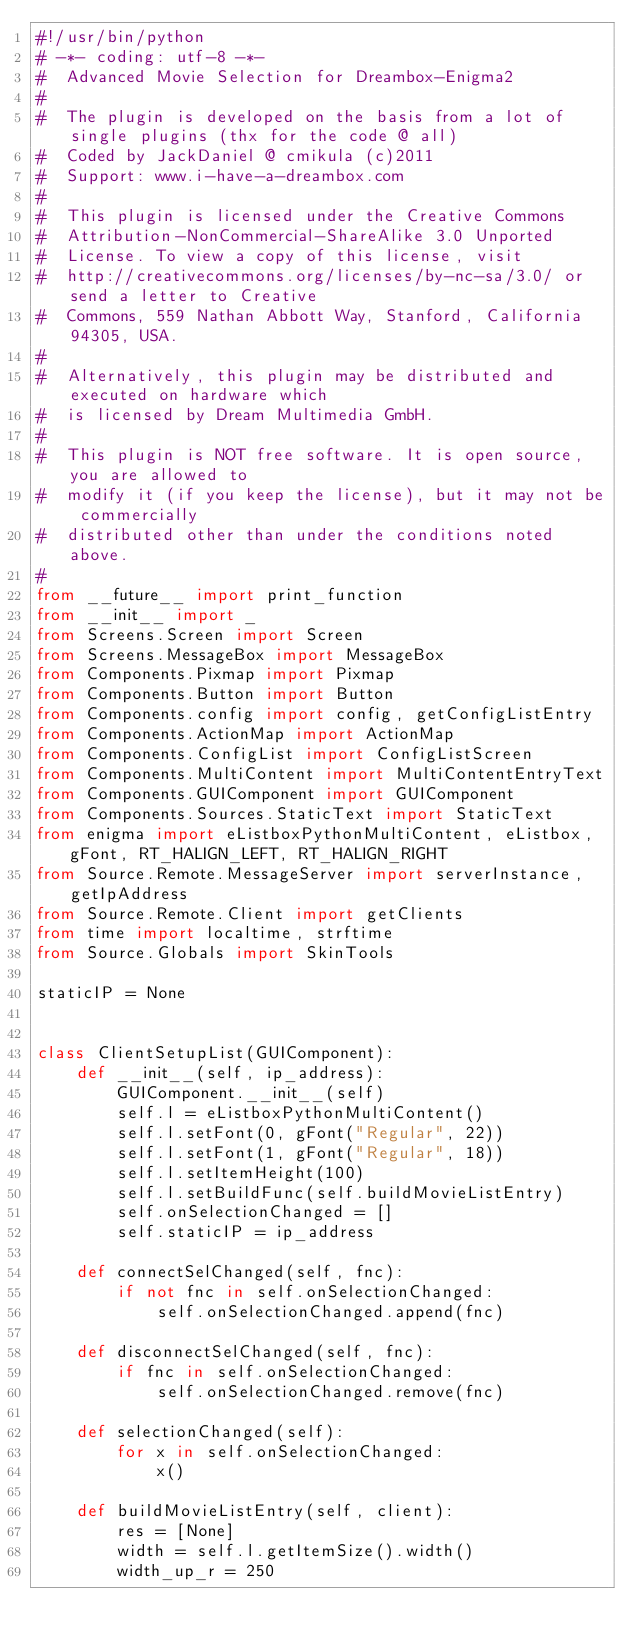<code> <loc_0><loc_0><loc_500><loc_500><_Python_>#!/usr/bin/python
# -*- coding: utf-8 -*-
#  Advanced Movie Selection for Dreambox-Enigma2
#
#  The plugin is developed on the basis from a lot of single plugins (thx for the code @ all)
#  Coded by JackDaniel @ cmikula (c)2011
#  Support: www.i-have-a-dreambox.com
#
#  This plugin is licensed under the Creative Commons
#  Attribution-NonCommercial-ShareAlike 3.0 Unported
#  License. To view a copy of this license, visit
#  http://creativecommons.org/licenses/by-nc-sa/3.0/ or send a letter to Creative
#  Commons, 559 Nathan Abbott Way, Stanford, California 94305, USA.
#
#  Alternatively, this plugin may be distributed and executed on hardware which
#  is licensed by Dream Multimedia GmbH.
#
#  This plugin is NOT free software. It is open source, you are allowed to
#  modify it (if you keep the license), but it may not be commercially
#  distributed other than under the conditions noted above.
#
from __future__ import print_function
from __init__ import _
from Screens.Screen import Screen
from Screens.MessageBox import MessageBox
from Components.Pixmap import Pixmap
from Components.Button import Button
from Components.config import config, getConfigListEntry
from Components.ActionMap import ActionMap
from Components.ConfigList import ConfigListScreen
from Components.MultiContent import MultiContentEntryText
from Components.GUIComponent import GUIComponent
from Components.Sources.StaticText import StaticText
from enigma import eListboxPythonMultiContent, eListbox, gFont, RT_HALIGN_LEFT, RT_HALIGN_RIGHT
from Source.Remote.MessageServer import serverInstance, getIpAddress
from Source.Remote.Client import getClients
from time import localtime, strftime
from Source.Globals import SkinTools

staticIP = None


class ClientSetupList(GUIComponent):
    def __init__(self, ip_address):
        GUIComponent.__init__(self)
        self.l = eListboxPythonMultiContent()
        self.l.setFont(0, gFont("Regular", 22))
        self.l.setFont(1, gFont("Regular", 18))
        self.l.setItemHeight(100)
        self.l.setBuildFunc(self.buildMovieListEntry)
        self.onSelectionChanged = []
        self.staticIP = ip_address

    def connectSelChanged(self, fnc):
        if not fnc in self.onSelectionChanged:
            self.onSelectionChanged.append(fnc)

    def disconnectSelChanged(self, fnc):
        if fnc in self.onSelectionChanged:
            self.onSelectionChanged.remove(fnc)

    def selectionChanged(self):
        for x in self.onSelectionChanged:
            x()

    def buildMovieListEntry(self, client):
        res = [None]
        width = self.l.getItemSize().width()
        width_up_r = 250</code> 